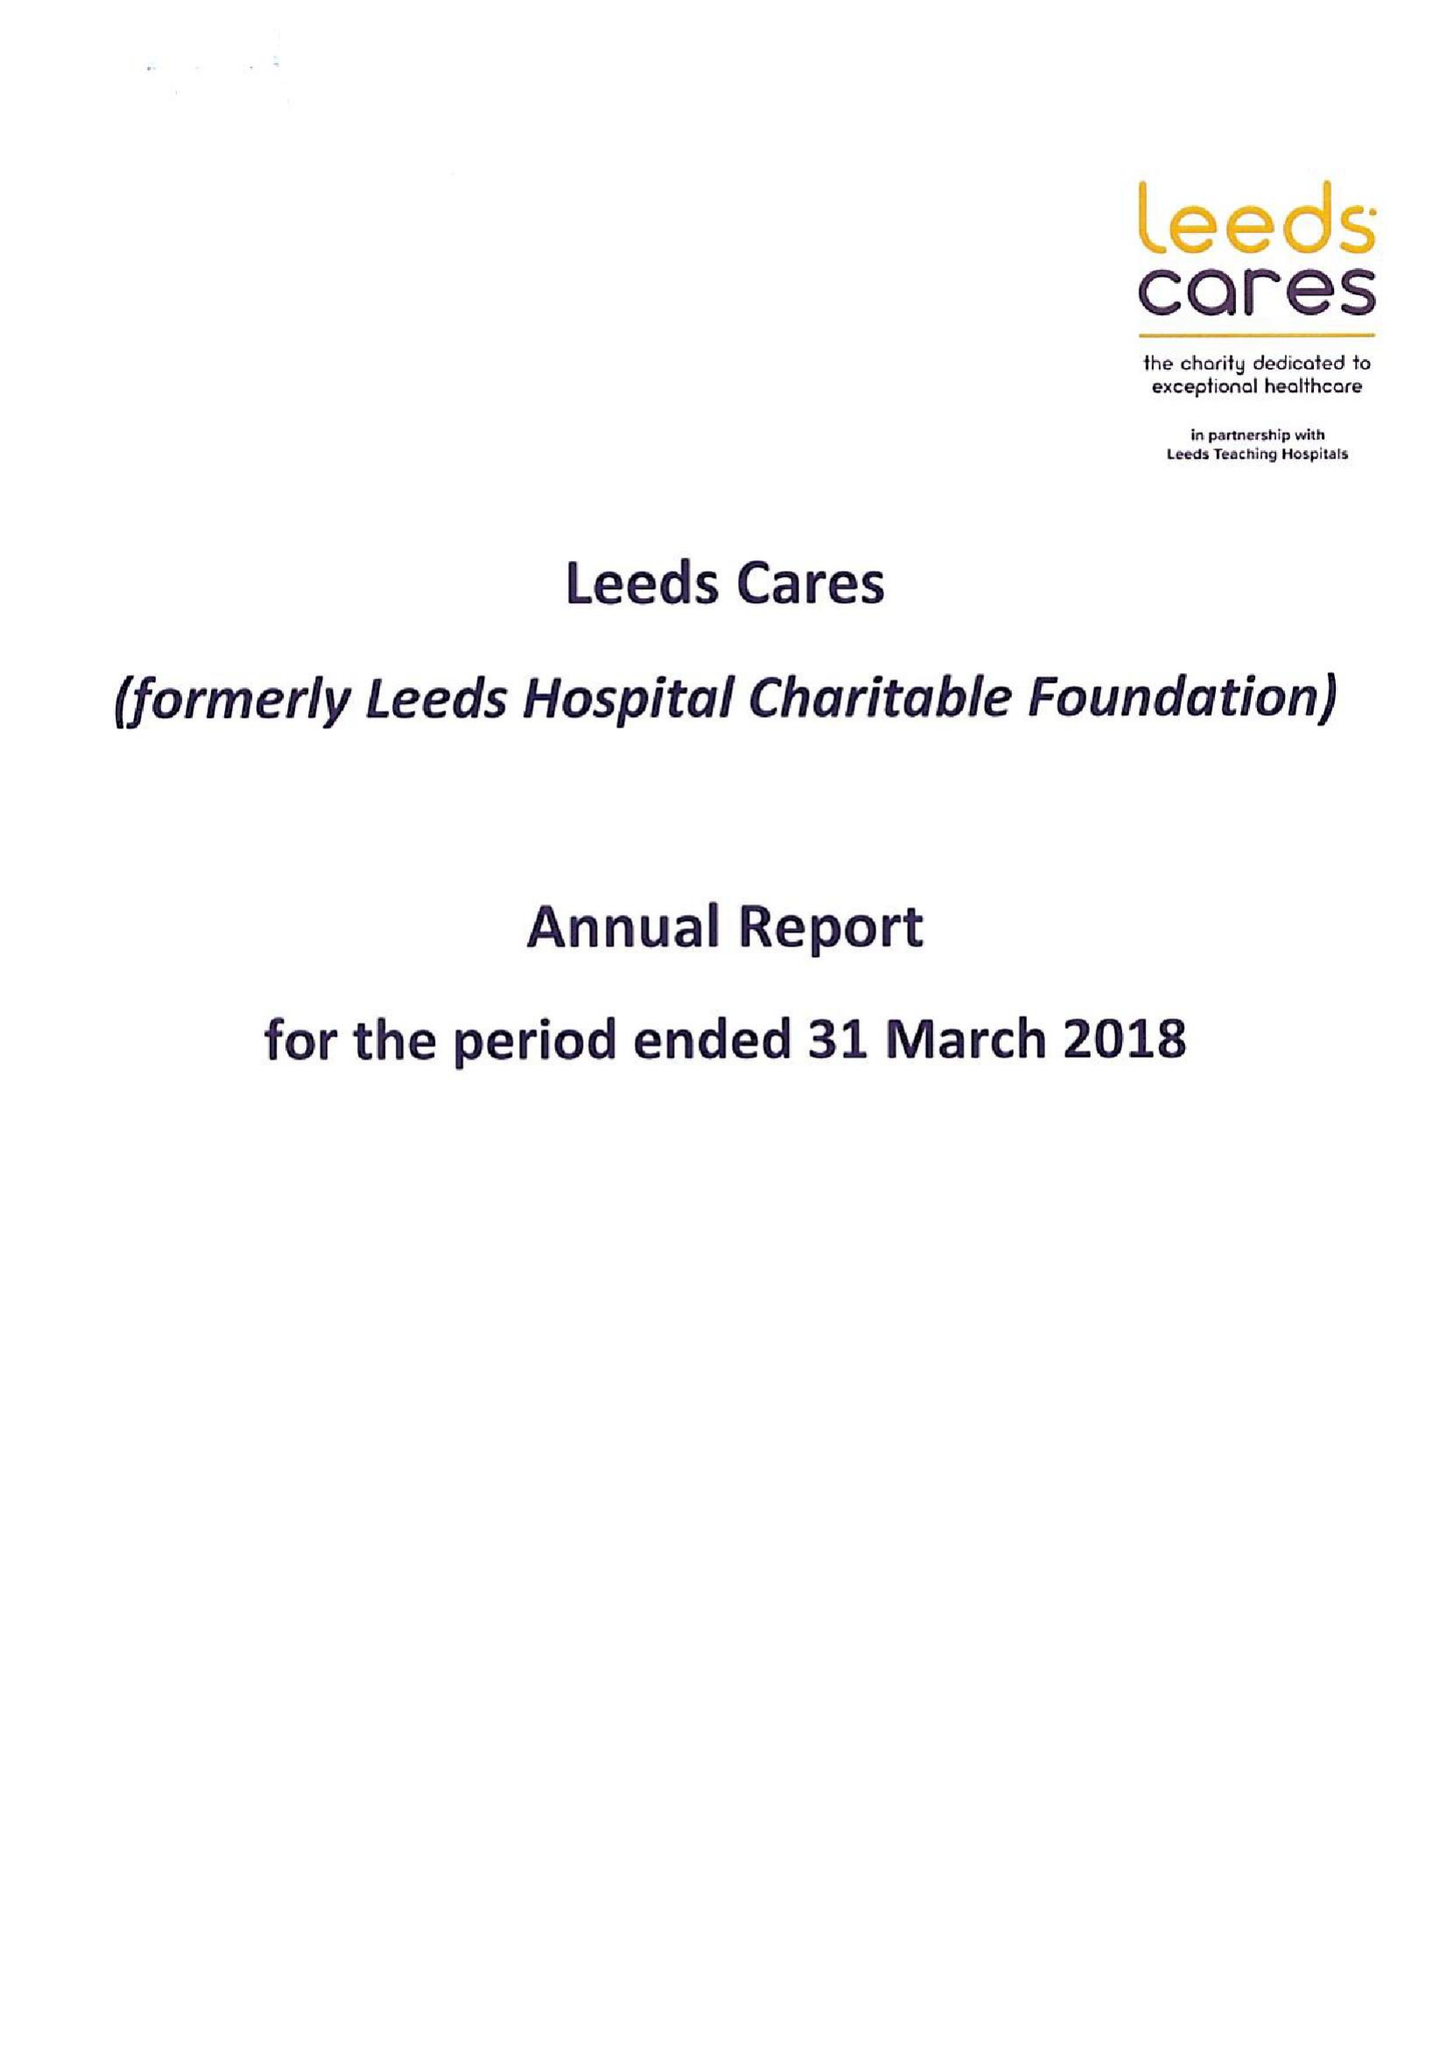What is the value for the report_date?
Answer the question using a single word or phrase. 2018-03-30 